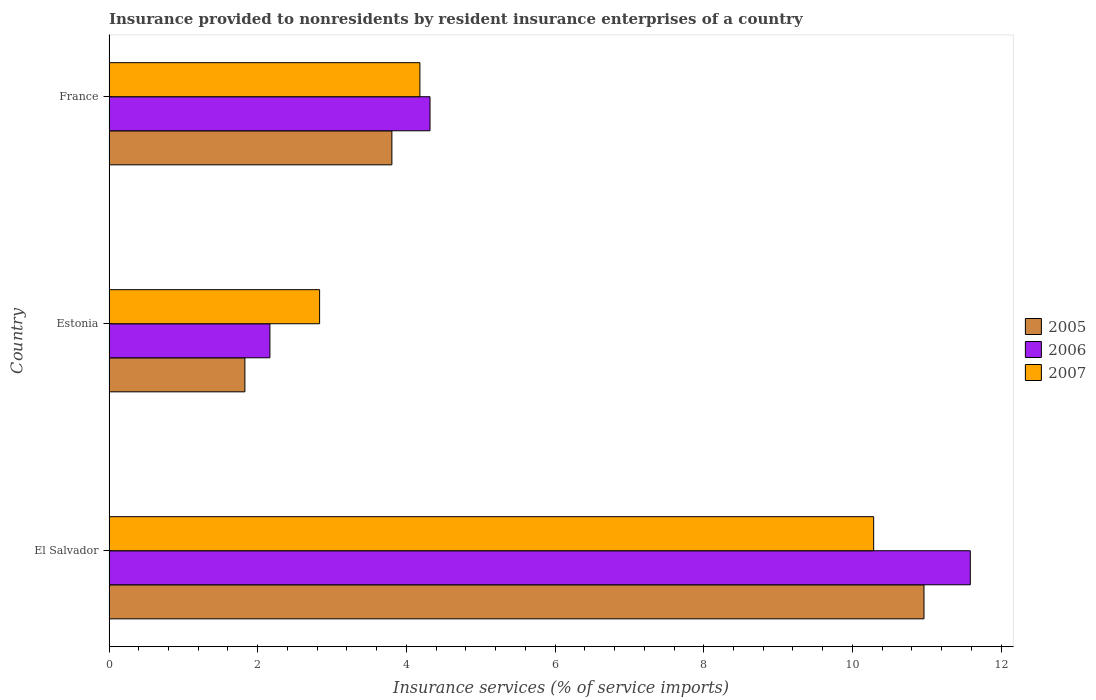Are the number of bars per tick equal to the number of legend labels?
Make the answer very short. Yes. Are the number of bars on each tick of the Y-axis equal?
Offer a terse response. Yes. How many bars are there on the 3rd tick from the top?
Your answer should be compact. 3. How many bars are there on the 1st tick from the bottom?
Your answer should be compact. 3. What is the label of the 3rd group of bars from the top?
Your response must be concise. El Salvador. What is the insurance provided to nonresidents in 2005 in Estonia?
Ensure brevity in your answer.  1.83. Across all countries, what is the maximum insurance provided to nonresidents in 2006?
Make the answer very short. 11.59. Across all countries, what is the minimum insurance provided to nonresidents in 2006?
Your answer should be very brief. 2.16. In which country was the insurance provided to nonresidents in 2006 maximum?
Offer a very short reply. El Salvador. In which country was the insurance provided to nonresidents in 2006 minimum?
Your answer should be very brief. Estonia. What is the total insurance provided to nonresidents in 2006 in the graph?
Offer a terse response. 18.07. What is the difference between the insurance provided to nonresidents in 2005 in El Salvador and that in France?
Offer a very short reply. 7.16. What is the difference between the insurance provided to nonresidents in 2005 in El Salvador and the insurance provided to nonresidents in 2007 in Estonia?
Give a very brief answer. 8.13. What is the average insurance provided to nonresidents in 2005 per country?
Offer a terse response. 5.53. What is the difference between the insurance provided to nonresidents in 2005 and insurance provided to nonresidents in 2006 in Estonia?
Ensure brevity in your answer.  -0.34. In how many countries, is the insurance provided to nonresidents in 2005 greater than 9.6 %?
Your answer should be very brief. 1. What is the ratio of the insurance provided to nonresidents in 2005 in El Salvador to that in Estonia?
Provide a succinct answer. 6. Is the difference between the insurance provided to nonresidents in 2005 in El Salvador and France greater than the difference between the insurance provided to nonresidents in 2006 in El Salvador and France?
Keep it short and to the point. No. What is the difference between the highest and the second highest insurance provided to nonresidents in 2005?
Keep it short and to the point. 7.16. What is the difference between the highest and the lowest insurance provided to nonresidents in 2006?
Ensure brevity in your answer.  9.42. What does the 2nd bar from the top in El Salvador represents?
Your response must be concise. 2006. Is it the case that in every country, the sum of the insurance provided to nonresidents in 2007 and insurance provided to nonresidents in 2006 is greater than the insurance provided to nonresidents in 2005?
Your answer should be compact. Yes. How many countries are there in the graph?
Your answer should be compact. 3. What is the difference between two consecutive major ticks on the X-axis?
Your answer should be very brief. 2. Are the values on the major ticks of X-axis written in scientific E-notation?
Offer a very short reply. No. Does the graph contain any zero values?
Your answer should be very brief. No. Does the graph contain grids?
Your answer should be compact. No. How many legend labels are there?
Make the answer very short. 3. How are the legend labels stacked?
Ensure brevity in your answer.  Vertical. What is the title of the graph?
Ensure brevity in your answer.  Insurance provided to nonresidents by resident insurance enterprises of a country. Does "1989" appear as one of the legend labels in the graph?
Offer a very short reply. No. What is the label or title of the X-axis?
Give a very brief answer. Insurance services (% of service imports). What is the Insurance services (% of service imports) of 2005 in El Salvador?
Make the answer very short. 10.96. What is the Insurance services (% of service imports) in 2006 in El Salvador?
Ensure brevity in your answer.  11.59. What is the Insurance services (% of service imports) of 2007 in El Salvador?
Provide a succinct answer. 10.29. What is the Insurance services (% of service imports) in 2005 in Estonia?
Your answer should be compact. 1.83. What is the Insurance services (% of service imports) of 2006 in Estonia?
Offer a very short reply. 2.16. What is the Insurance services (% of service imports) of 2007 in Estonia?
Keep it short and to the point. 2.83. What is the Insurance services (% of service imports) in 2005 in France?
Give a very brief answer. 3.81. What is the Insurance services (% of service imports) in 2006 in France?
Provide a succinct answer. 4.32. What is the Insurance services (% of service imports) of 2007 in France?
Make the answer very short. 4.18. Across all countries, what is the maximum Insurance services (% of service imports) of 2005?
Ensure brevity in your answer.  10.96. Across all countries, what is the maximum Insurance services (% of service imports) in 2006?
Provide a succinct answer. 11.59. Across all countries, what is the maximum Insurance services (% of service imports) in 2007?
Provide a succinct answer. 10.29. Across all countries, what is the minimum Insurance services (% of service imports) in 2005?
Offer a very short reply. 1.83. Across all countries, what is the minimum Insurance services (% of service imports) of 2006?
Provide a short and direct response. 2.16. Across all countries, what is the minimum Insurance services (% of service imports) of 2007?
Offer a very short reply. 2.83. What is the total Insurance services (% of service imports) of 2005 in the graph?
Your answer should be very brief. 16.6. What is the total Insurance services (% of service imports) of 2006 in the graph?
Your response must be concise. 18.07. What is the total Insurance services (% of service imports) in 2007 in the graph?
Give a very brief answer. 17.3. What is the difference between the Insurance services (% of service imports) of 2005 in El Salvador and that in Estonia?
Ensure brevity in your answer.  9.13. What is the difference between the Insurance services (% of service imports) in 2006 in El Salvador and that in Estonia?
Your response must be concise. 9.42. What is the difference between the Insurance services (% of service imports) in 2007 in El Salvador and that in Estonia?
Offer a terse response. 7.45. What is the difference between the Insurance services (% of service imports) in 2005 in El Salvador and that in France?
Your answer should be compact. 7.16. What is the difference between the Insurance services (% of service imports) of 2006 in El Salvador and that in France?
Make the answer very short. 7.27. What is the difference between the Insurance services (% of service imports) in 2007 in El Salvador and that in France?
Offer a terse response. 6.1. What is the difference between the Insurance services (% of service imports) of 2005 in Estonia and that in France?
Your answer should be compact. -1.98. What is the difference between the Insurance services (% of service imports) of 2006 in Estonia and that in France?
Provide a succinct answer. -2.15. What is the difference between the Insurance services (% of service imports) of 2007 in Estonia and that in France?
Ensure brevity in your answer.  -1.35. What is the difference between the Insurance services (% of service imports) in 2005 in El Salvador and the Insurance services (% of service imports) in 2006 in Estonia?
Provide a short and direct response. 8.8. What is the difference between the Insurance services (% of service imports) in 2005 in El Salvador and the Insurance services (% of service imports) in 2007 in Estonia?
Keep it short and to the point. 8.13. What is the difference between the Insurance services (% of service imports) of 2006 in El Salvador and the Insurance services (% of service imports) of 2007 in Estonia?
Provide a short and direct response. 8.75. What is the difference between the Insurance services (% of service imports) in 2005 in El Salvador and the Insurance services (% of service imports) in 2006 in France?
Your answer should be very brief. 6.64. What is the difference between the Insurance services (% of service imports) of 2005 in El Salvador and the Insurance services (% of service imports) of 2007 in France?
Provide a succinct answer. 6.78. What is the difference between the Insurance services (% of service imports) in 2006 in El Salvador and the Insurance services (% of service imports) in 2007 in France?
Ensure brevity in your answer.  7.4. What is the difference between the Insurance services (% of service imports) in 2005 in Estonia and the Insurance services (% of service imports) in 2006 in France?
Give a very brief answer. -2.49. What is the difference between the Insurance services (% of service imports) in 2005 in Estonia and the Insurance services (% of service imports) in 2007 in France?
Ensure brevity in your answer.  -2.35. What is the difference between the Insurance services (% of service imports) in 2006 in Estonia and the Insurance services (% of service imports) in 2007 in France?
Your response must be concise. -2.02. What is the average Insurance services (% of service imports) of 2005 per country?
Your response must be concise. 5.53. What is the average Insurance services (% of service imports) of 2006 per country?
Give a very brief answer. 6.02. What is the average Insurance services (% of service imports) in 2007 per country?
Your response must be concise. 5.77. What is the difference between the Insurance services (% of service imports) in 2005 and Insurance services (% of service imports) in 2006 in El Salvador?
Provide a succinct answer. -0.62. What is the difference between the Insurance services (% of service imports) in 2005 and Insurance services (% of service imports) in 2007 in El Salvador?
Your response must be concise. 0.68. What is the difference between the Insurance services (% of service imports) in 2006 and Insurance services (% of service imports) in 2007 in El Salvador?
Ensure brevity in your answer.  1.3. What is the difference between the Insurance services (% of service imports) in 2005 and Insurance services (% of service imports) in 2006 in Estonia?
Provide a short and direct response. -0.34. What is the difference between the Insurance services (% of service imports) of 2005 and Insurance services (% of service imports) of 2007 in Estonia?
Provide a succinct answer. -1.01. What is the difference between the Insurance services (% of service imports) in 2006 and Insurance services (% of service imports) in 2007 in Estonia?
Offer a very short reply. -0.67. What is the difference between the Insurance services (% of service imports) of 2005 and Insurance services (% of service imports) of 2006 in France?
Offer a very short reply. -0.51. What is the difference between the Insurance services (% of service imports) of 2005 and Insurance services (% of service imports) of 2007 in France?
Your answer should be very brief. -0.38. What is the difference between the Insurance services (% of service imports) of 2006 and Insurance services (% of service imports) of 2007 in France?
Your answer should be very brief. 0.14. What is the ratio of the Insurance services (% of service imports) in 2005 in El Salvador to that in Estonia?
Your response must be concise. 6. What is the ratio of the Insurance services (% of service imports) of 2006 in El Salvador to that in Estonia?
Provide a short and direct response. 5.35. What is the ratio of the Insurance services (% of service imports) of 2007 in El Salvador to that in Estonia?
Provide a succinct answer. 3.63. What is the ratio of the Insurance services (% of service imports) in 2005 in El Salvador to that in France?
Provide a succinct answer. 2.88. What is the ratio of the Insurance services (% of service imports) in 2006 in El Salvador to that in France?
Offer a very short reply. 2.68. What is the ratio of the Insurance services (% of service imports) of 2007 in El Salvador to that in France?
Give a very brief answer. 2.46. What is the ratio of the Insurance services (% of service imports) of 2005 in Estonia to that in France?
Make the answer very short. 0.48. What is the ratio of the Insurance services (% of service imports) of 2006 in Estonia to that in France?
Provide a succinct answer. 0.5. What is the ratio of the Insurance services (% of service imports) of 2007 in Estonia to that in France?
Your answer should be compact. 0.68. What is the difference between the highest and the second highest Insurance services (% of service imports) of 2005?
Make the answer very short. 7.16. What is the difference between the highest and the second highest Insurance services (% of service imports) in 2006?
Offer a very short reply. 7.27. What is the difference between the highest and the second highest Insurance services (% of service imports) in 2007?
Give a very brief answer. 6.1. What is the difference between the highest and the lowest Insurance services (% of service imports) of 2005?
Provide a short and direct response. 9.13. What is the difference between the highest and the lowest Insurance services (% of service imports) of 2006?
Give a very brief answer. 9.42. What is the difference between the highest and the lowest Insurance services (% of service imports) in 2007?
Your response must be concise. 7.45. 